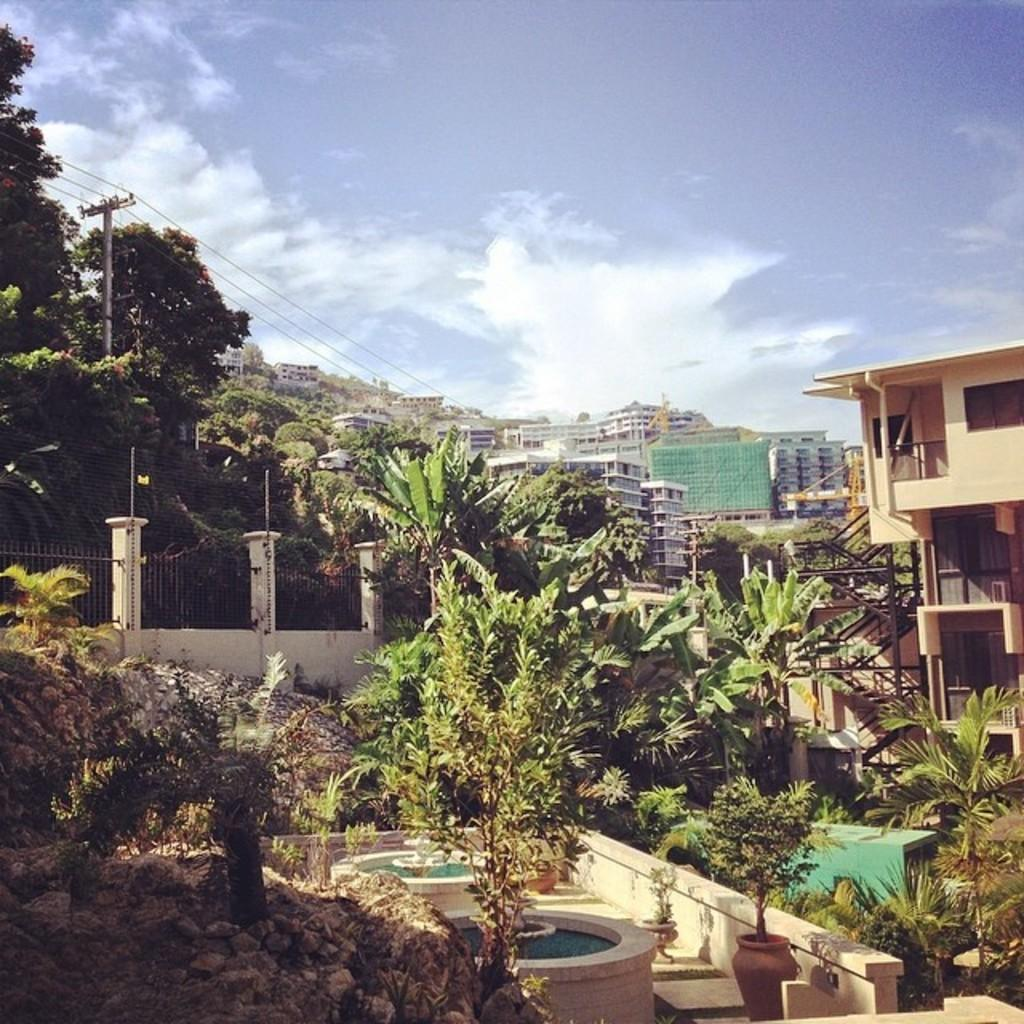What type of natural elements can be seen in the image? There are trees and plants in the image. What man-made structure is present in the image? There is a fence in the image. Are there any containers for plants visible in the image? Yes, there are plant pots in the image. What type of infrastructure can be seen in the image? There are poles with wires in the image. What can be seen in the background of the image? There are buildings and the sky visible in the background of the image. What type of bread can be seen in the image? There is no bread or loaf present in the image. What year is depicted in the image? The image does not depict a specific year; it is a still image of a scene. 